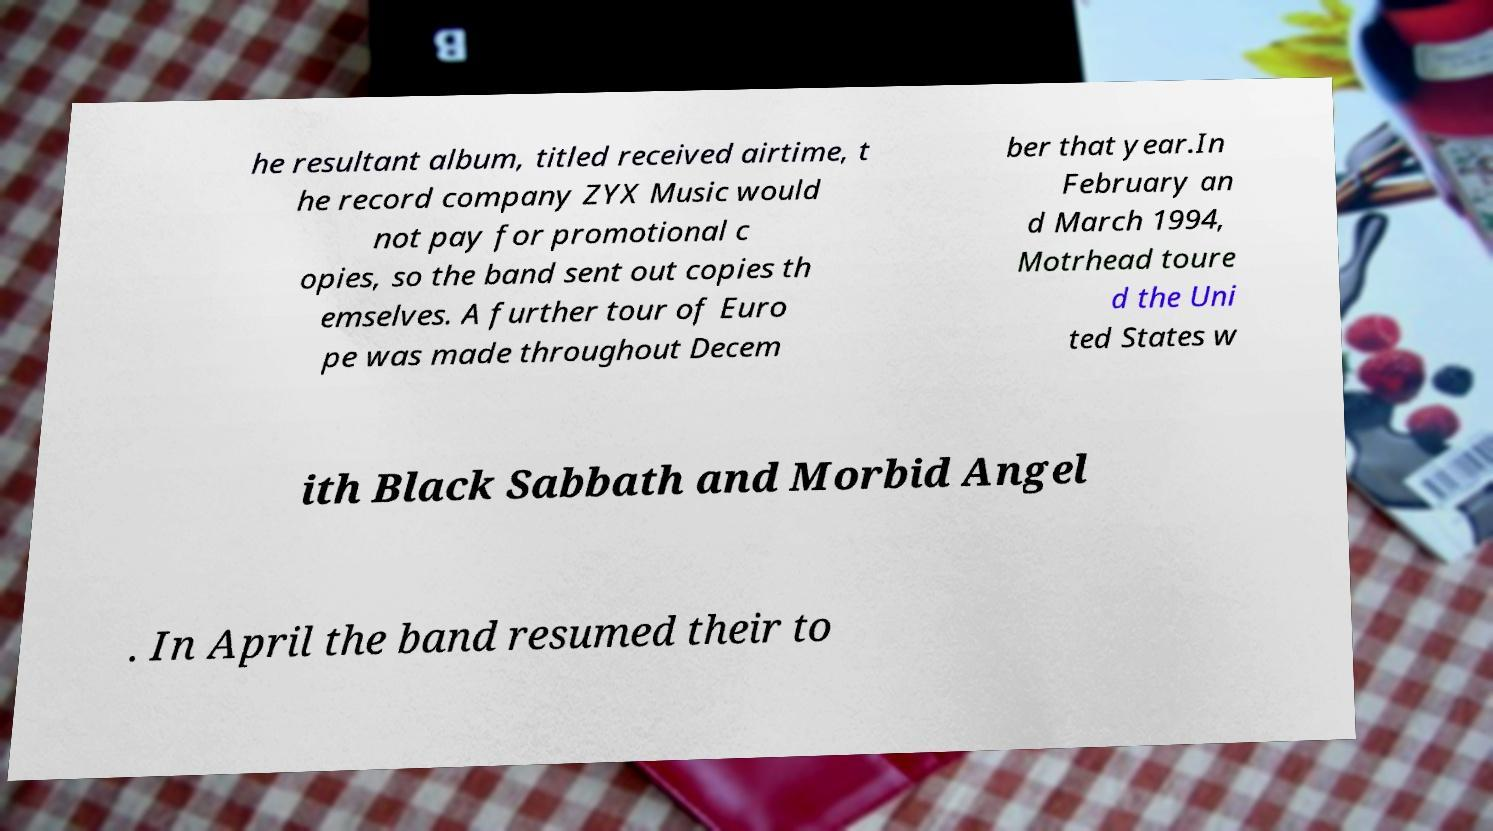I need the written content from this picture converted into text. Can you do that? he resultant album, titled received airtime, t he record company ZYX Music would not pay for promotional c opies, so the band sent out copies th emselves. A further tour of Euro pe was made throughout Decem ber that year.In February an d March 1994, Motrhead toure d the Uni ted States w ith Black Sabbath and Morbid Angel . In April the band resumed their to 